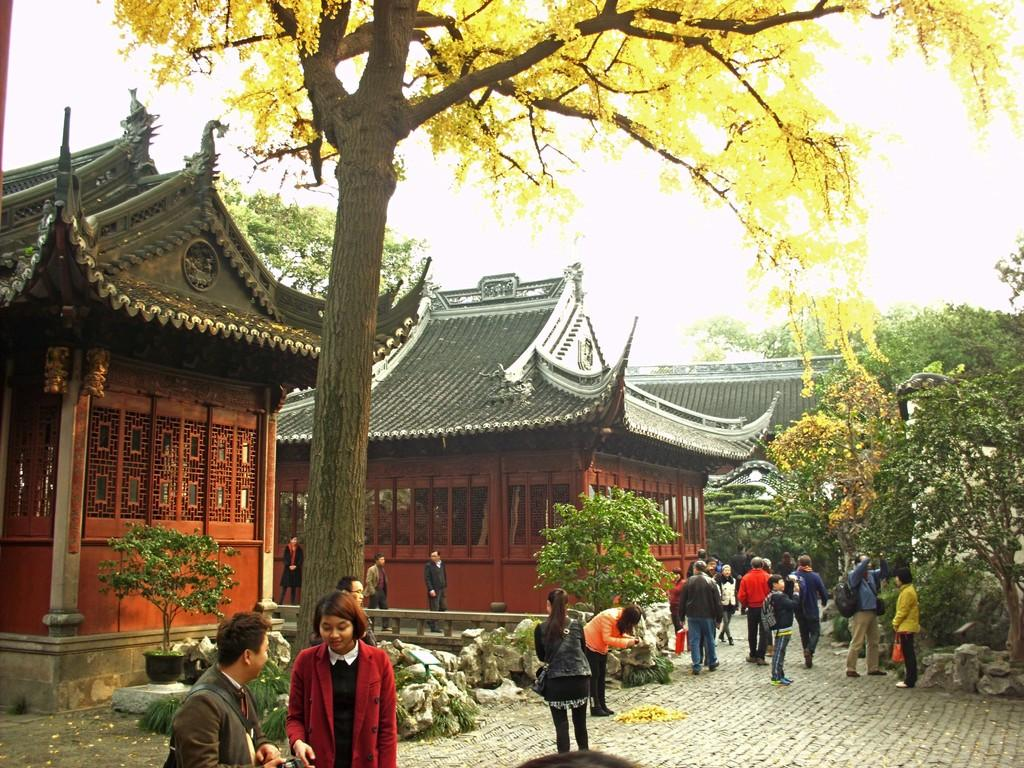What type of structures can be seen in the image? There are houses in the image. What type of vegetation is present in the image? There are trees in the image. What are the people in the image doing? There are people walking in the image. What color is the ball in the pocket of the person walking in the image? There is no ball or pocket visible in the image. 